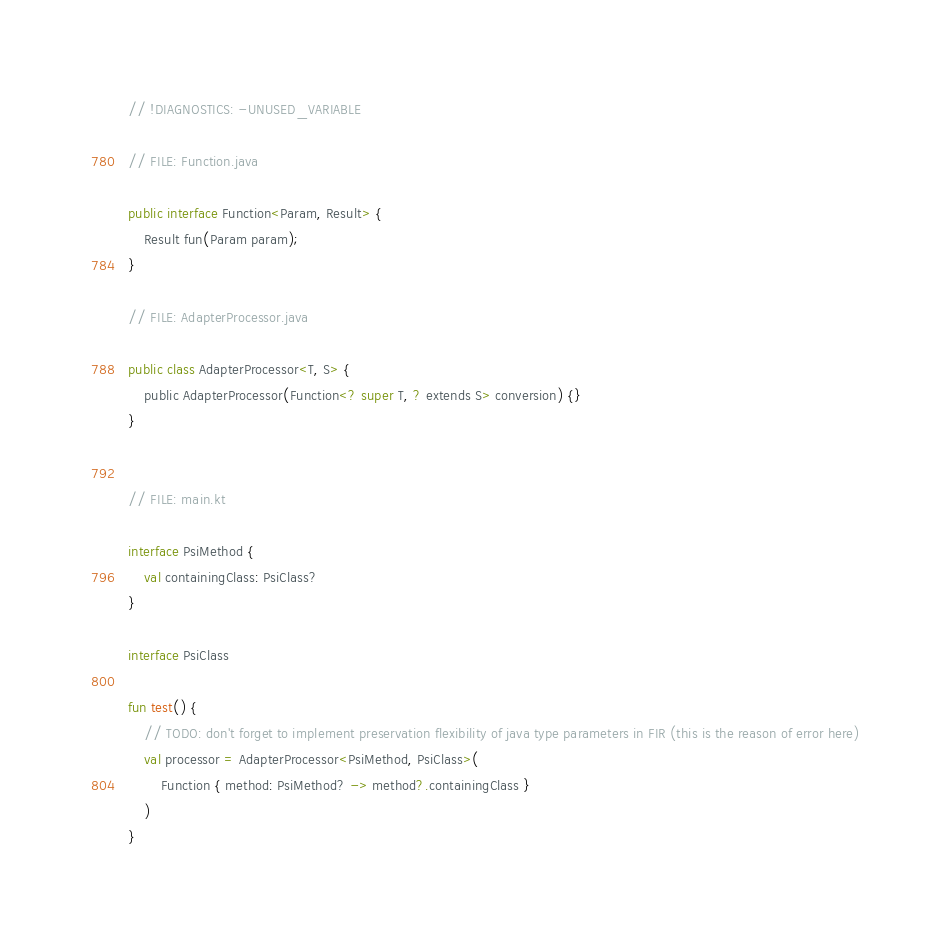Convert code to text. <code><loc_0><loc_0><loc_500><loc_500><_Kotlin_>// !DIAGNOSTICS: -UNUSED_VARIABLE

// FILE: Function.java

public interface Function<Param, Result> {
    Result fun(Param param);
}

// FILE: AdapterProcessor.java

public class AdapterProcessor<T, S> {
    public AdapterProcessor(Function<? super T, ? extends S> conversion) {}
}


// FILE: main.kt

interface PsiMethod {
    val containingClass: PsiClass?
}

interface PsiClass

fun test() {
    // TODO: don't forget to implement preservation flexibility of java type parameters in FIR (this is the reason of error here)
    val processor = AdapterProcessor<PsiMethod, PsiClass>(
        Function { method: PsiMethod? -> method?.containingClass }
    )
}</code> 